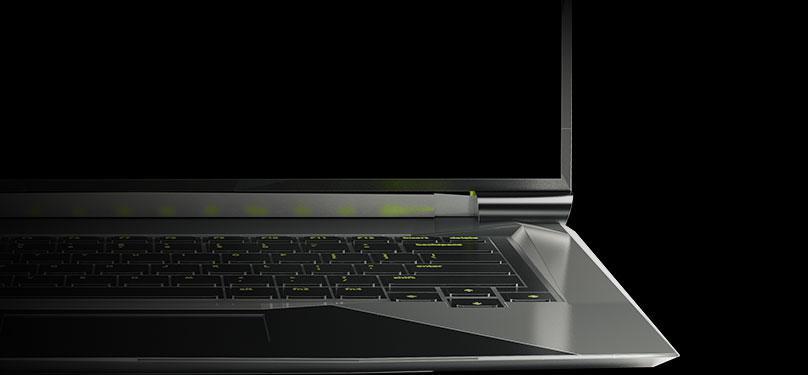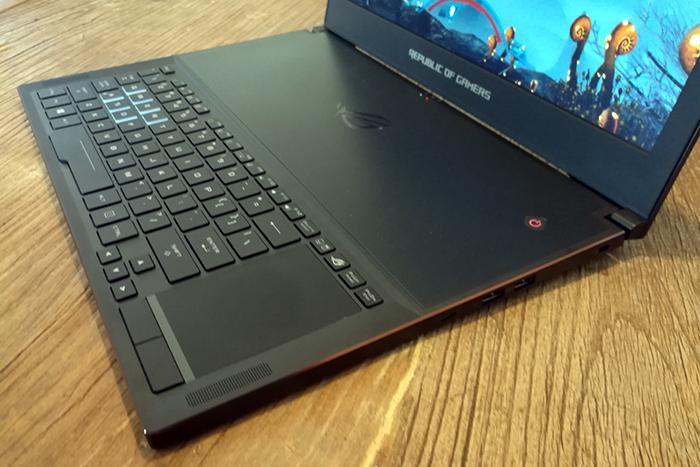The first image is the image on the left, the second image is the image on the right. For the images shown, is this caption "there is a laptop sitting on a wooden table" true? Answer yes or no. Yes. The first image is the image on the left, the second image is the image on the right. Examine the images to the left and right. Is the description "Wires are coming out the right side of the computer in at least one of the images." accurate? Answer yes or no. No. 